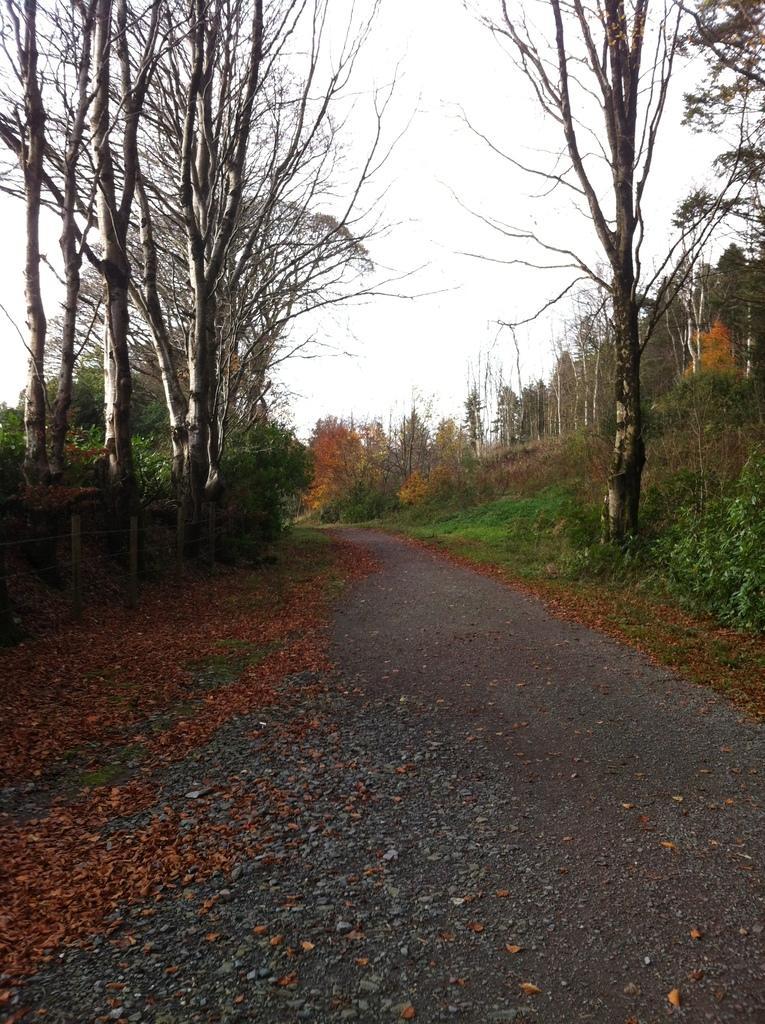Please provide a concise description of this image. In this picture there is a road, beside the road I can see many trees, plants, grass and leaves. At the top there is a sky. 